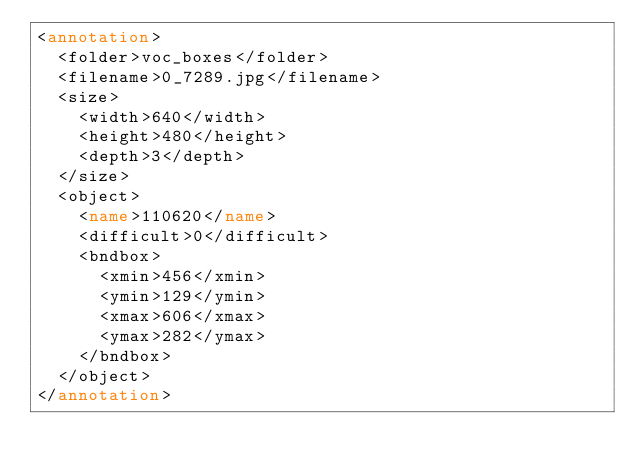<code> <loc_0><loc_0><loc_500><loc_500><_XML_><annotation>
  <folder>voc_boxes</folder>
  <filename>0_7289.jpg</filename>
  <size>
    <width>640</width>
    <height>480</height>
    <depth>3</depth>
  </size>
  <object>
    <name>110620</name>
    <difficult>0</difficult>
    <bndbox>
      <xmin>456</xmin>
      <ymin>129</ymin>
      <xmax>606</xmax>
      <ymax>282</ymax>
    </bndbox>
  </object>
</annotation></code> 